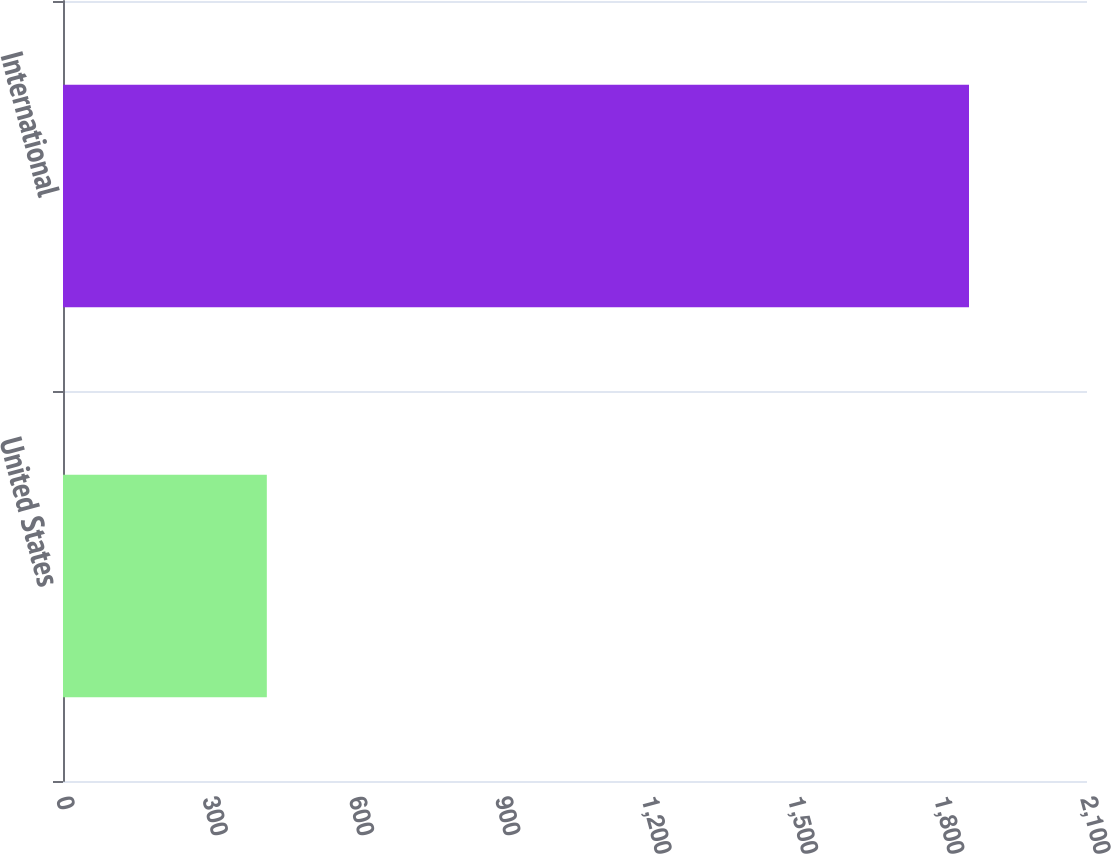<chart> <loc_0><loc_0><loc_500><loc_500><bar_chart><fcel>United States<fcel>International<nl><fcel>418<fcel>1858<nl></chart> 